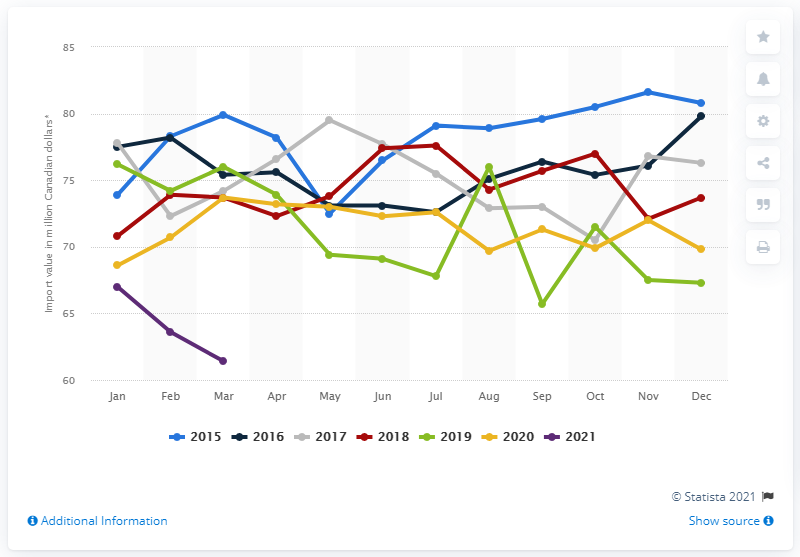Mention a couple of crucial points in this snapshot. The import value of fresh, frozen, and canned fruit and vegetable juices in Canada in March 2021 was CAD 61.4 million. 